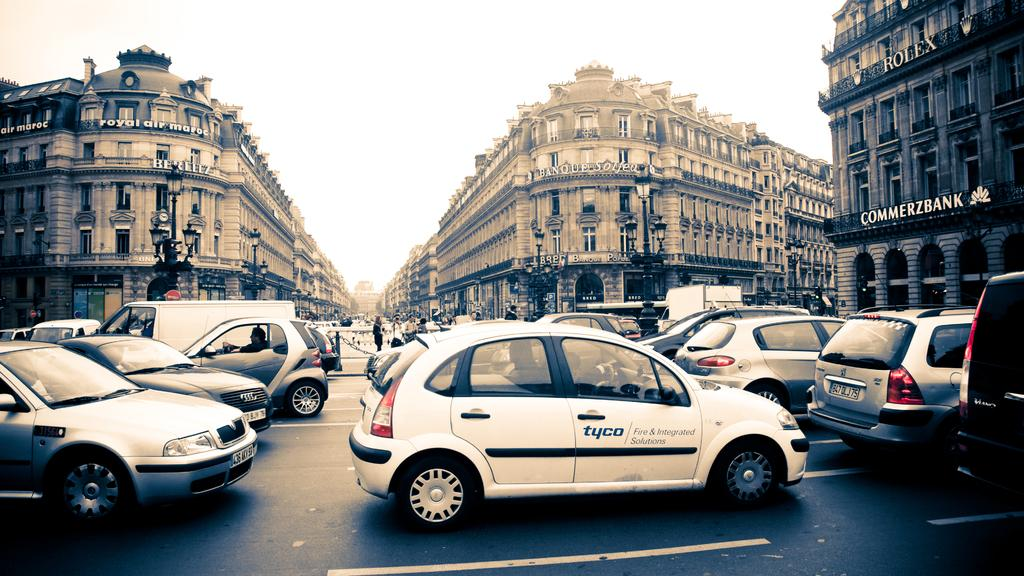<image>
Summarize the visual content of the image. cars on a european street where one is from Tyco 